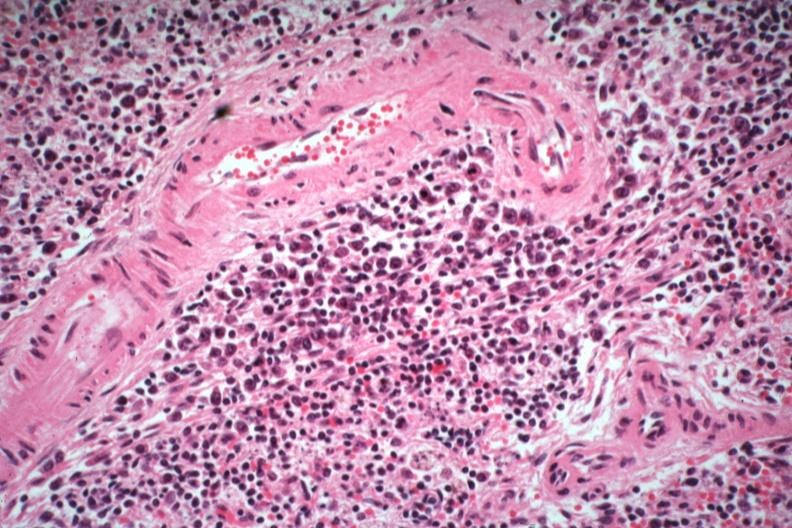what is present?
Answer the question using a single word or phrase. Immunoblastic reaction characteristic of viral infection 